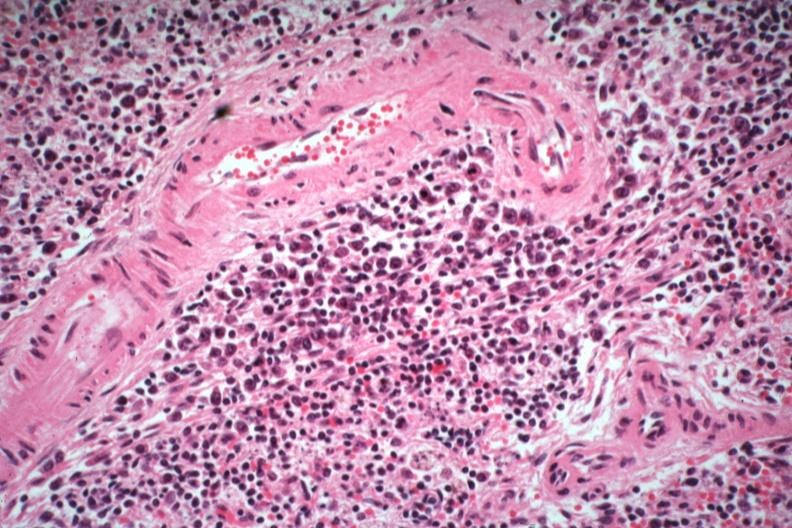what is present?
Answer the question using a single word or phrase. Immunoblastic reaction characteristic of viral infection 